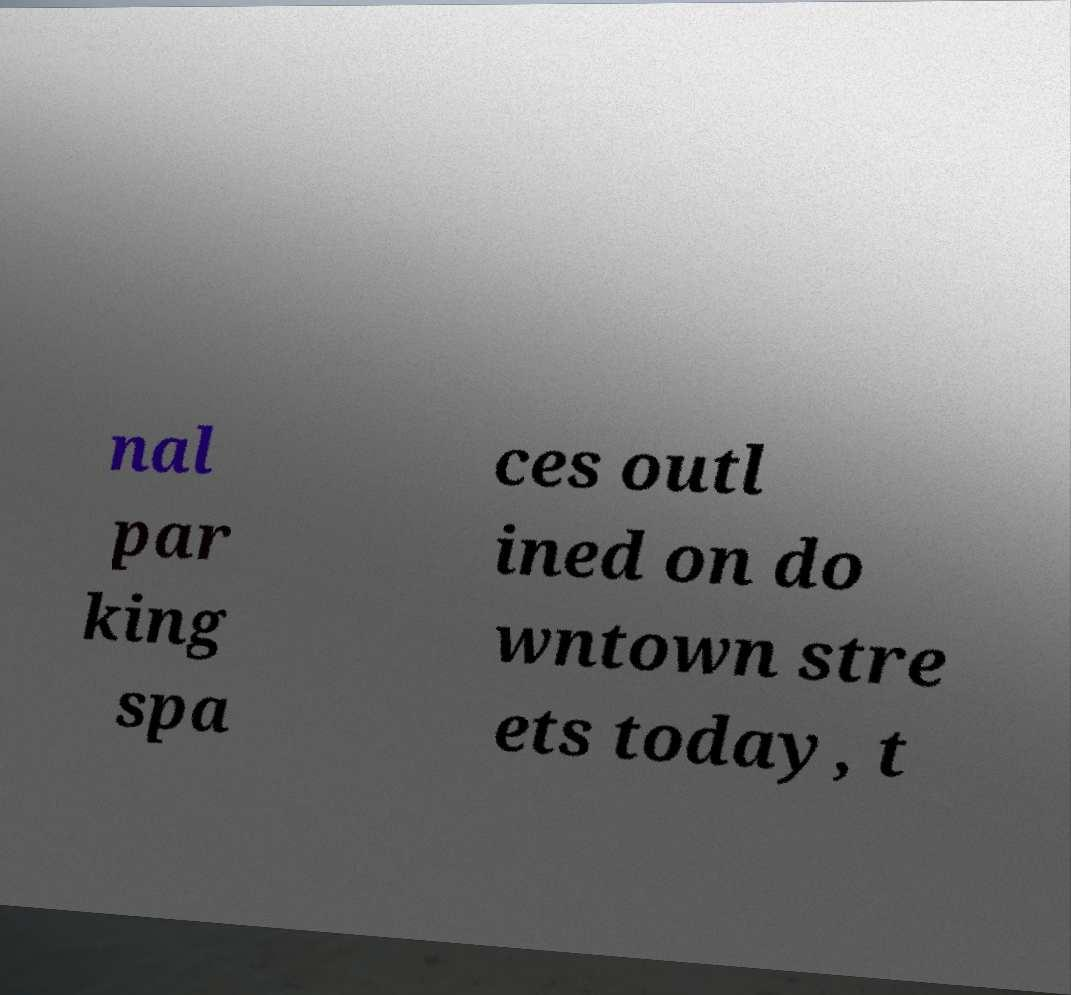For documentation purposes, I need the text within this image transcribed. Could you provide that? nal par king spa ces outl ined on do wntown stre ets today, t 